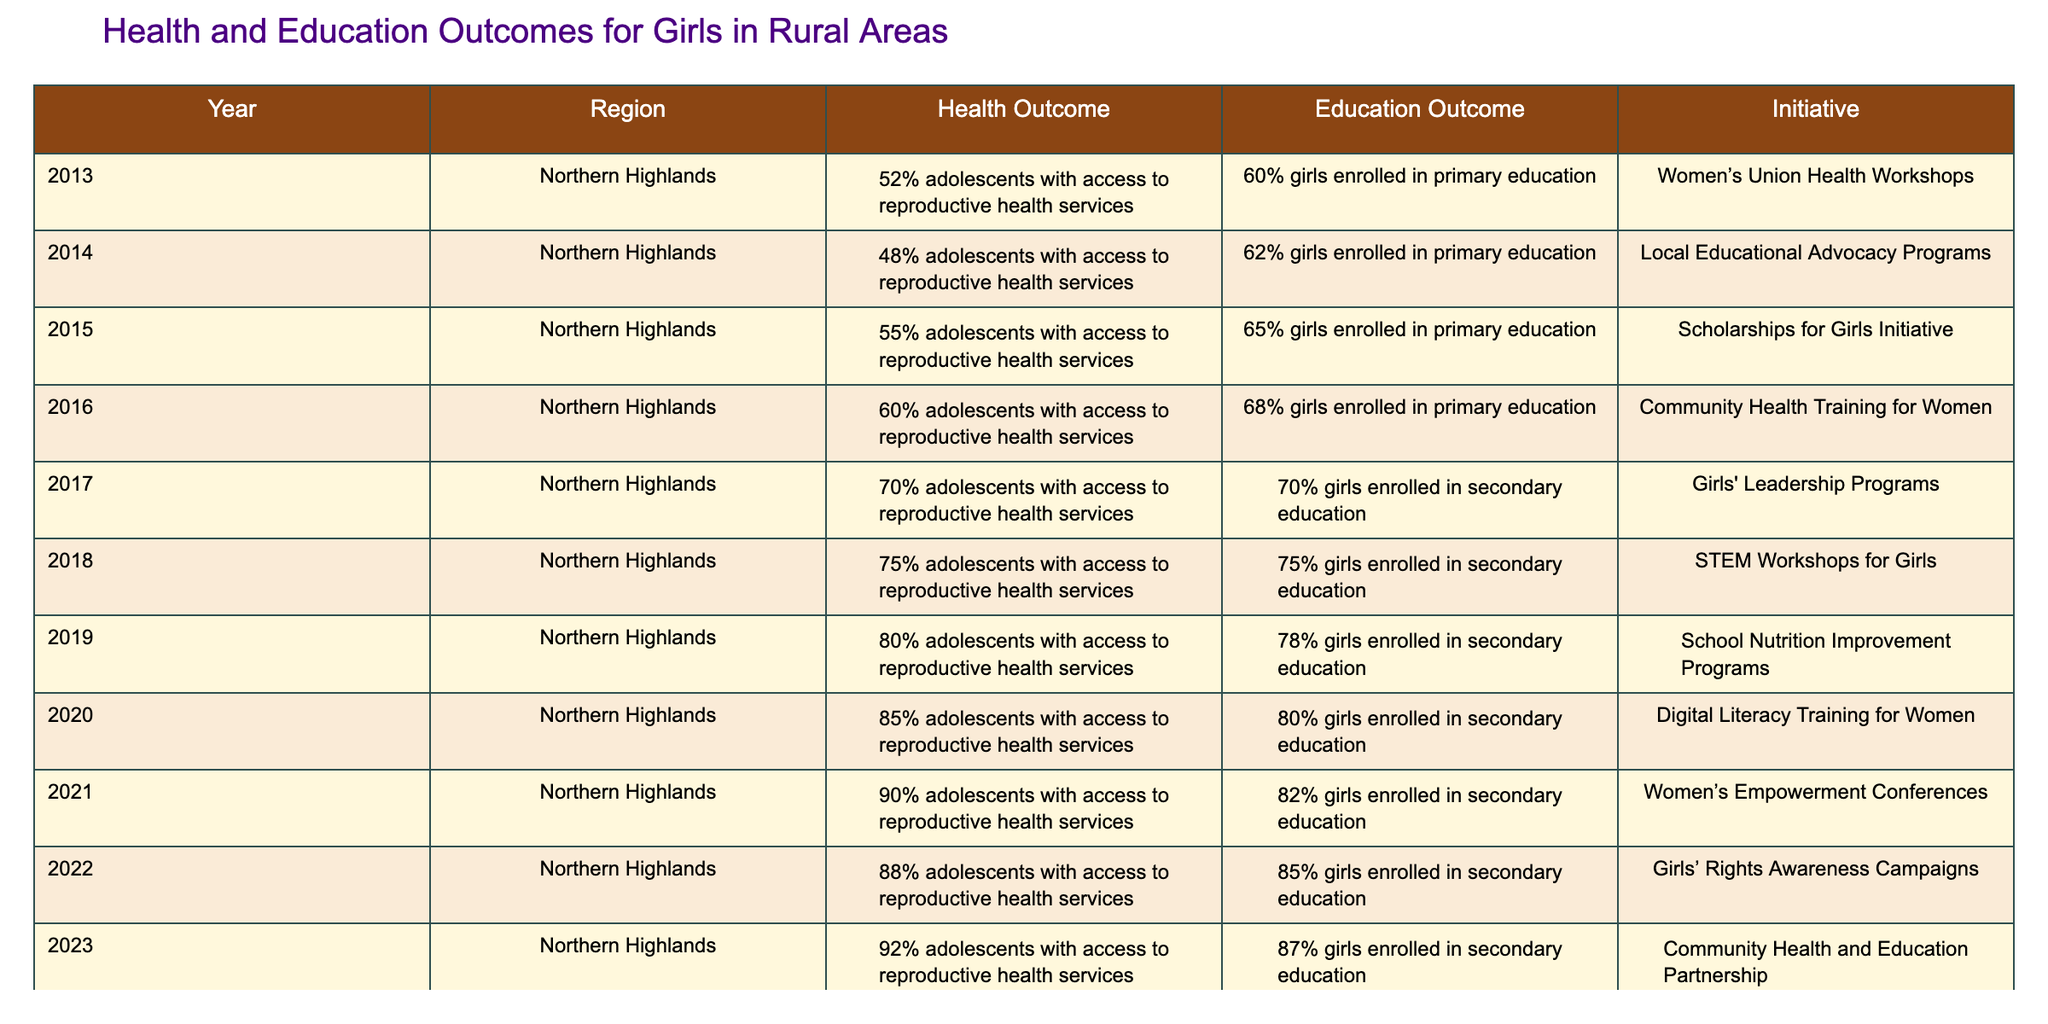What was the health outcome for adolescents in the Northern Highlands in 2015? In 2015, the health outcome for adolescents in the Northern Highlands showed that 55% had access to reproductive health services, as indicated in the relevant row of the table.
Answer: 55% What initiative was implemented in 2020? The initiative in 2020 was the Digital Literacy Training for Women, which is listed under the initiative column for that year in the table.
Answer: Digital Literacy Training for Women What was the percentage increase in girls enrolled in secondary education from 2017 to 2023? In 2017, 70% of girls were enrolled in secondary education and this increased to 87% in 2023. The difference can be calculated as 87% - 70% = 17%.
Answer: 17% Did the percentage of adolescents with access to reproductive health services decrease in any year? Analyzing the data, there is no year where the percentage of adolescents with access to reproductive health services decreased; it continuously increased from 52% in 2013 to 92% in 2023.
Answer: No What is the average percentage of girls enrolled in primary education from 2013 to 2015? The percentages for girls enrolled in primary education from 2013 to 2015 are 60%, 62%, and 65%. The average can be calculated by summing these values (60 + 62 + 65 = 187), and then dividing by 3, giving 187 / 3 = 62.33%.
Answer: 62.33% 